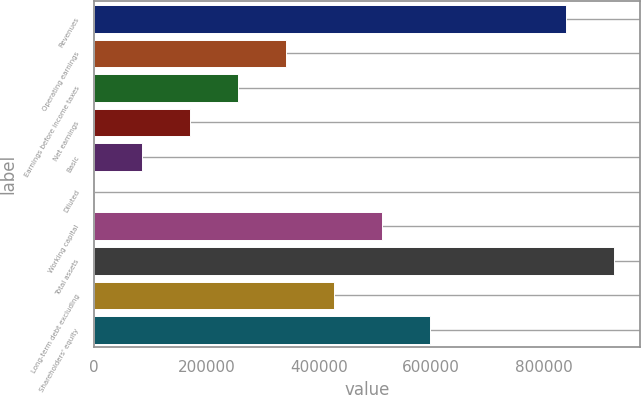Convert chart. <chart><loc_0><loc_0><loc_500><loc_500><bar_chart><fcel>Revenues<fcel>Operating earnings<fcel>Earnings before income taxes<fcel>Net earnings<fcel>Basic<fcel>Diluted<fcel>Working capital<fcel>Total assets<fcel>Long-term debt excluding<fcel>Shareholders' equity<nl><fcel>839587<fcel>341701<fcel>256276<fcel>170851<fcel>85425.7<fcel>0.59<fcel>512551<fcel>925012<fcel>427126<fcel>597977<nl></chart> 